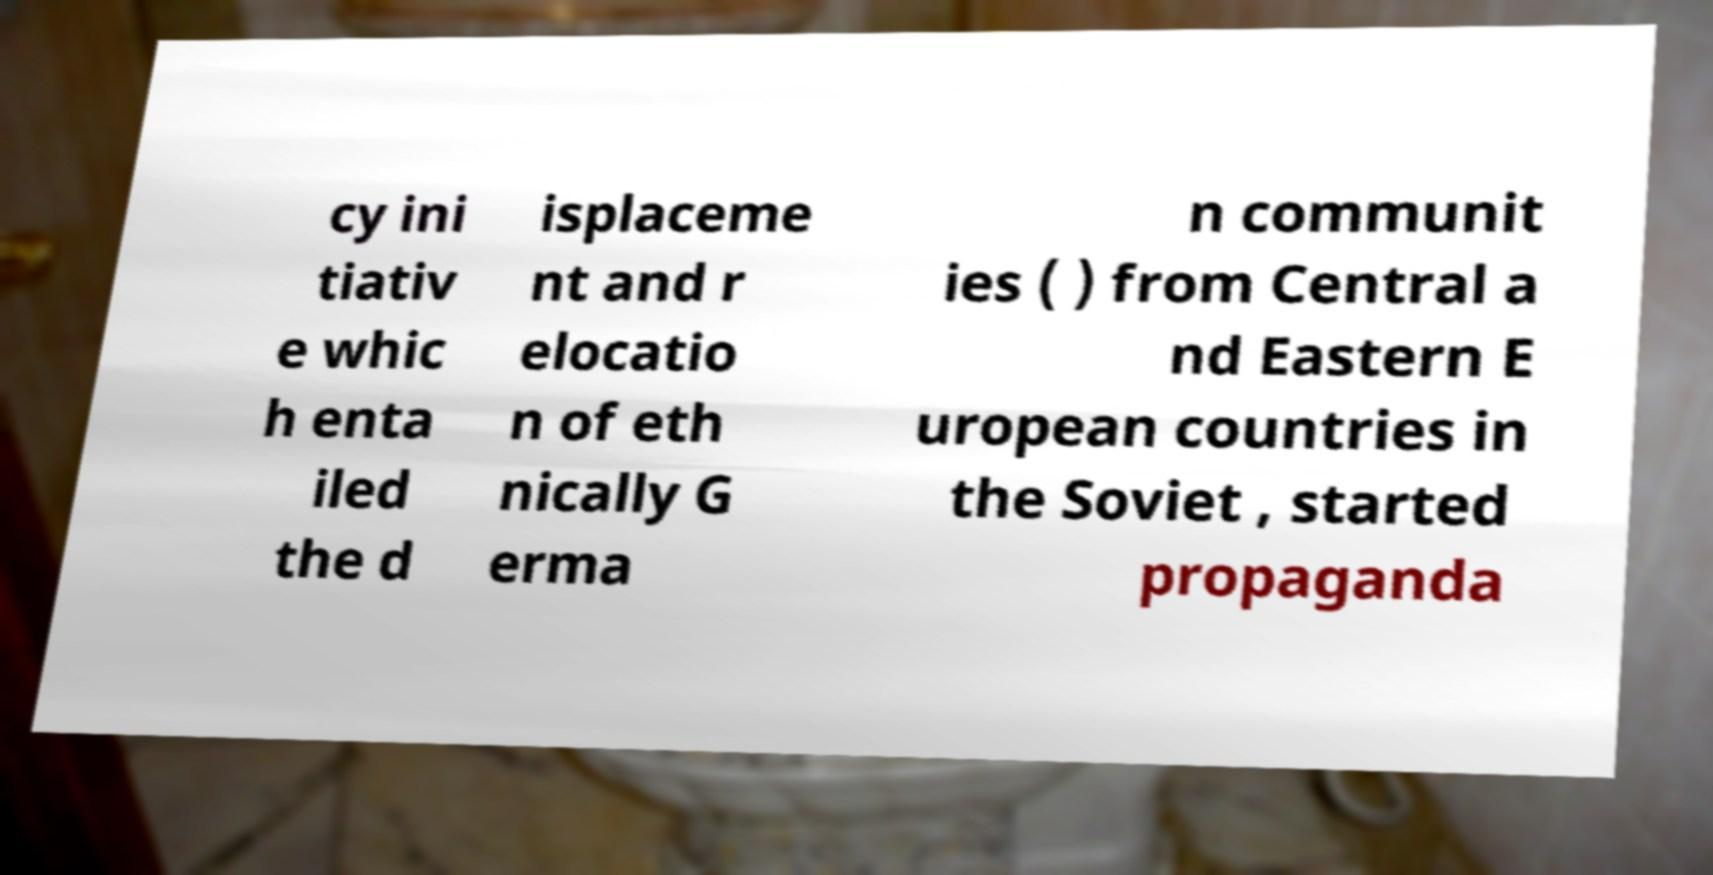Please read and relay the text visible in this image. What does it say? cy ini tiativ e whic h enta iled the d isplaceme nt and r elocatio n of eth nically G erma n communit ies ( ) from Central a nd Eastern E uropean countries in the Soviet , started propaganda 